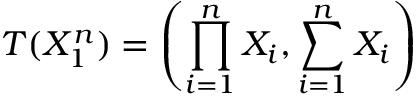Convert formula to latex. <formula><loc_0><loc_0><loc_500><loc_500>T ( X _ { 1 } ^ { n } ) = \left ( \prod _ { i = 1 } ^ { n } { X _ { i } } , \sum _ { i = 1 } ^ { n } X _ { i } \right )</formula> 